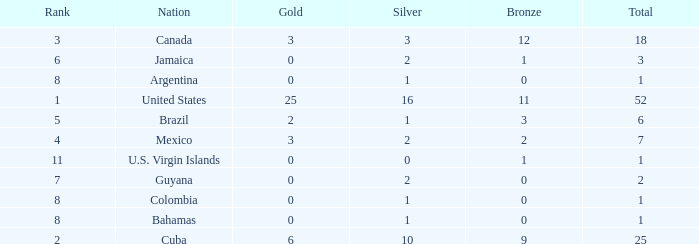What is the fewest number of silver medals a nation who ranked below 8 received? 0.0. 